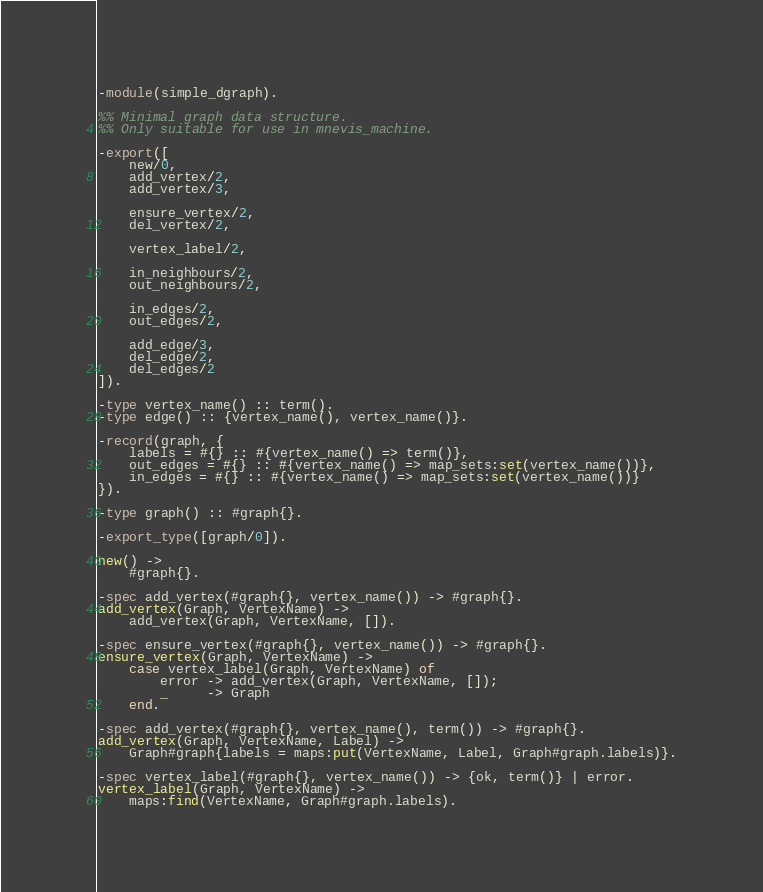<code> <loc_0><loc_0><loc_500><loc_500><_Erlang_>-module(simple_dgraph).

%% Minimal graph data structure.
%% Only suitable for use in mnevis_machine.

-export([
    new/0,
    add_vertex/2,
    add_vertex/3,

    ensure_vertex/2,
    del_vertex/2,

    vertex_label/2,

    in_neighbours/2,
    out_neighbours/2,

    in_edges/2,
    out_edges/2,

    add_edge/3,
    del_edge/2,
    del_edges/2
]).

-type vertex_name() :: term().
-type edge() :: {vertex_name(), vertex_name()}.

-record(graph, {
    labels = #{} :: #{vertex_name() => term()},
    out_edges = #{} :: #{vertex_name() => map_sets:set(vertex_name())},
    in_edges = #{} :: #{vertex_name() => map_sets:set(vertex_name())}
}).

-type graph() :: #graph{}.

-export_type([graph/0]).

new() ->
    #graph{}.

-spec add_vertex(#graph{}, vertex_name()) -> #graph{}.
add_vertex(Graph, VertexName) ->
    add_vertex(Graph, VertexName, []).

-spec ensure_vertex(#graph{}, vertex_name()) -> #graph{}.
ensure_vertex(Graph, VertexName) ->
    case vertex_label(Graph, VertexName) of
        error -> add_vertex(Graph, VertexName, []);
        _     -> Graph
    end.

-spec add_vertex(#graph{}, vertex_name(), term()) -> #graph{}.
add_vertex(Graph, VertexName, Label) ->
    Graph#graph{labels = maps:put(VertexName, Label, Graph#graph.labels)}.

-spec vertex_label(#graph{}, vertex_name()) -> {ok, term()} | error.
vertex_label(Graph, VertexName) ->
    maps:find(VertexName, Graph#graph.labels).
</code> 